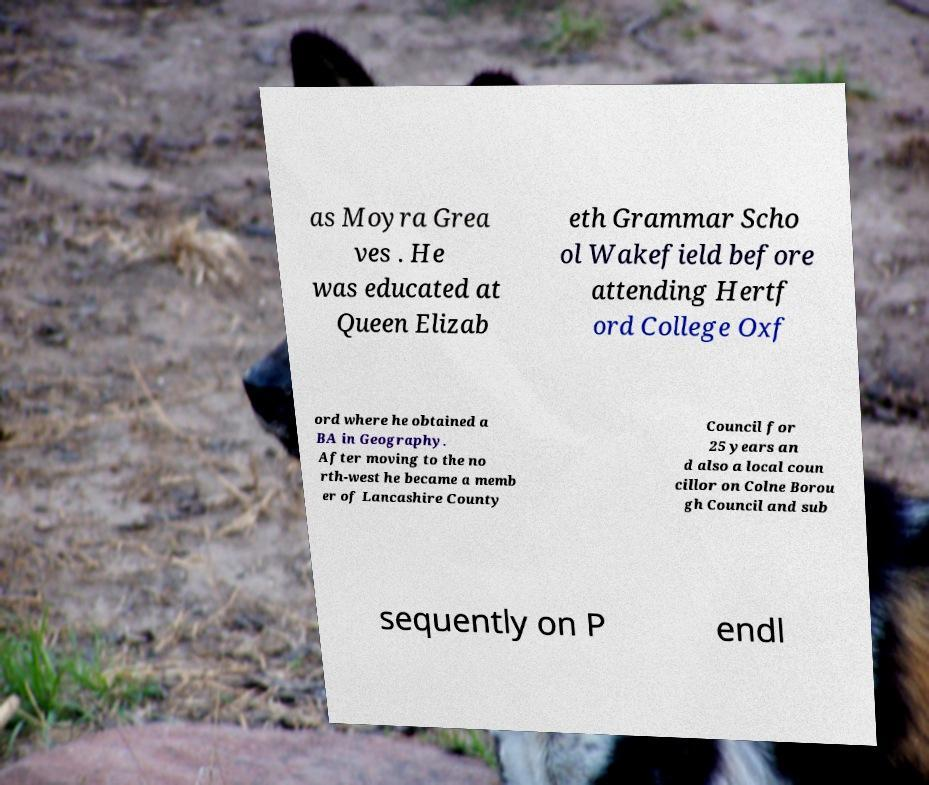Can you accurately transcribe the text from the provided image for me? as Moyra Grea ves . He was educated at Queen Elizab eth Grammar Scho ol Wakefield before attending Hertf ord College Oxf ord where he obtained a BA in Geography. After moving to the no rth-west he became a memb er of Lancashire County Council for 25 years an d also a local coun cillor on Colne Borou gh Council and sub sequently on P endl 